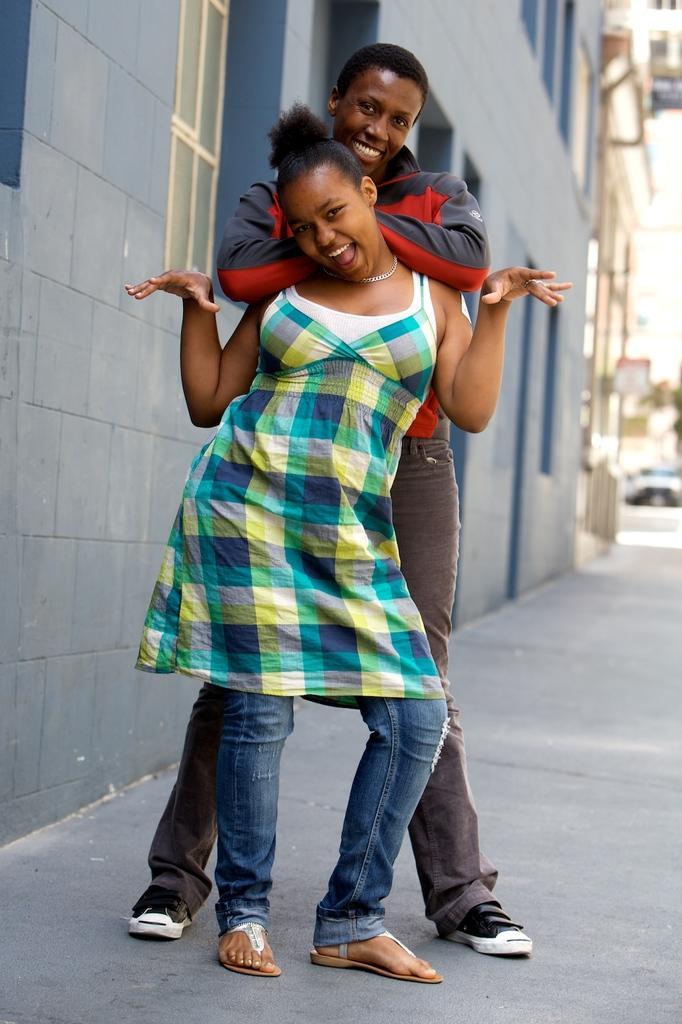How would you summarize this image in a sentence or two? In this image, we can see a woman and man are standing and smiling. Background we can see a building with wall and window. Right side of the image, we can see a blur view. 